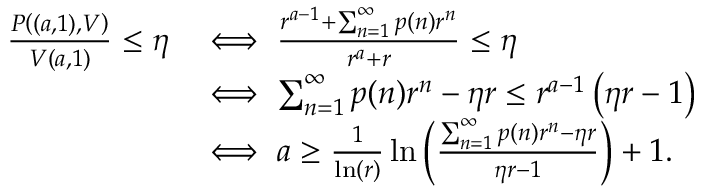Convert formula to latex. <formula><loc_0><loc_0><loc_500><loc_500>\begin{array} { r l } { \frac { P \left ( ( a , 1 ) , V \right ) } { V ( a , 1 ) } \leq \eta } & { \iff \frac { r ^ { a - 1 } + \sum _ { n = 1 } ^ { \infty } p ( n ) r ^ { n } } { r ^ { a } + r } \leq \eta } \\ & { \iff \sum _ { n = 1 } ^ { \infty } p ( n ) r ^ { n } - \eta r \leq r ^ { a - 1 } \left ( \eta r - 1 \right ) } \\ & { \iff a \geq \frac { 1 } { \ln ( r ) } \ln \left ( \frac { \sum _ { n = 1 } ^ { \infty } p ( n ) r ^ { n } - \eta r } { \eta r - 1 } \right ) + 1 . } \end{array}</formula> 